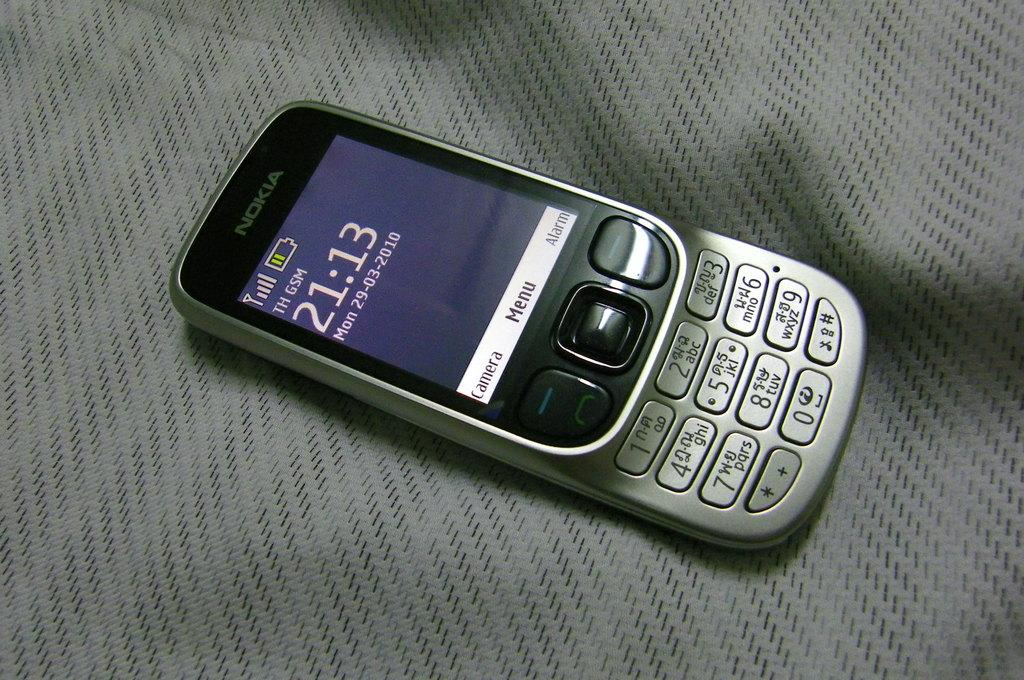Provide a one-sentence caption for the provided image. An old Nokia phone displays the time 21:13 on its screen. 